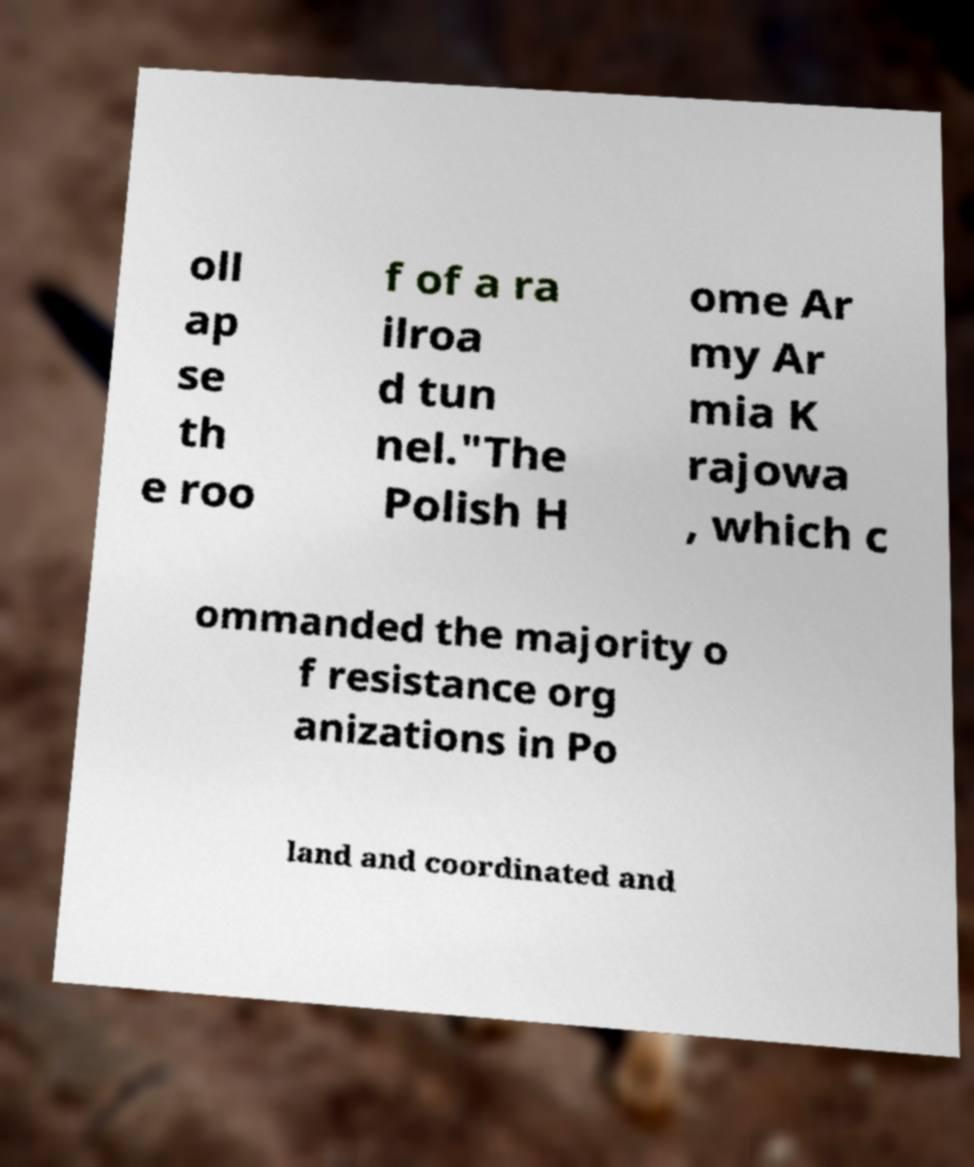Please read and relay the text visible in this image. What does it say? oll ap se th e roo f of a ra ilroa d tun nel."The Polish H ome Ar my Ar mia K rajowa , which c ommanded the majority o f resistance org anizations in Po land and coordinated and 